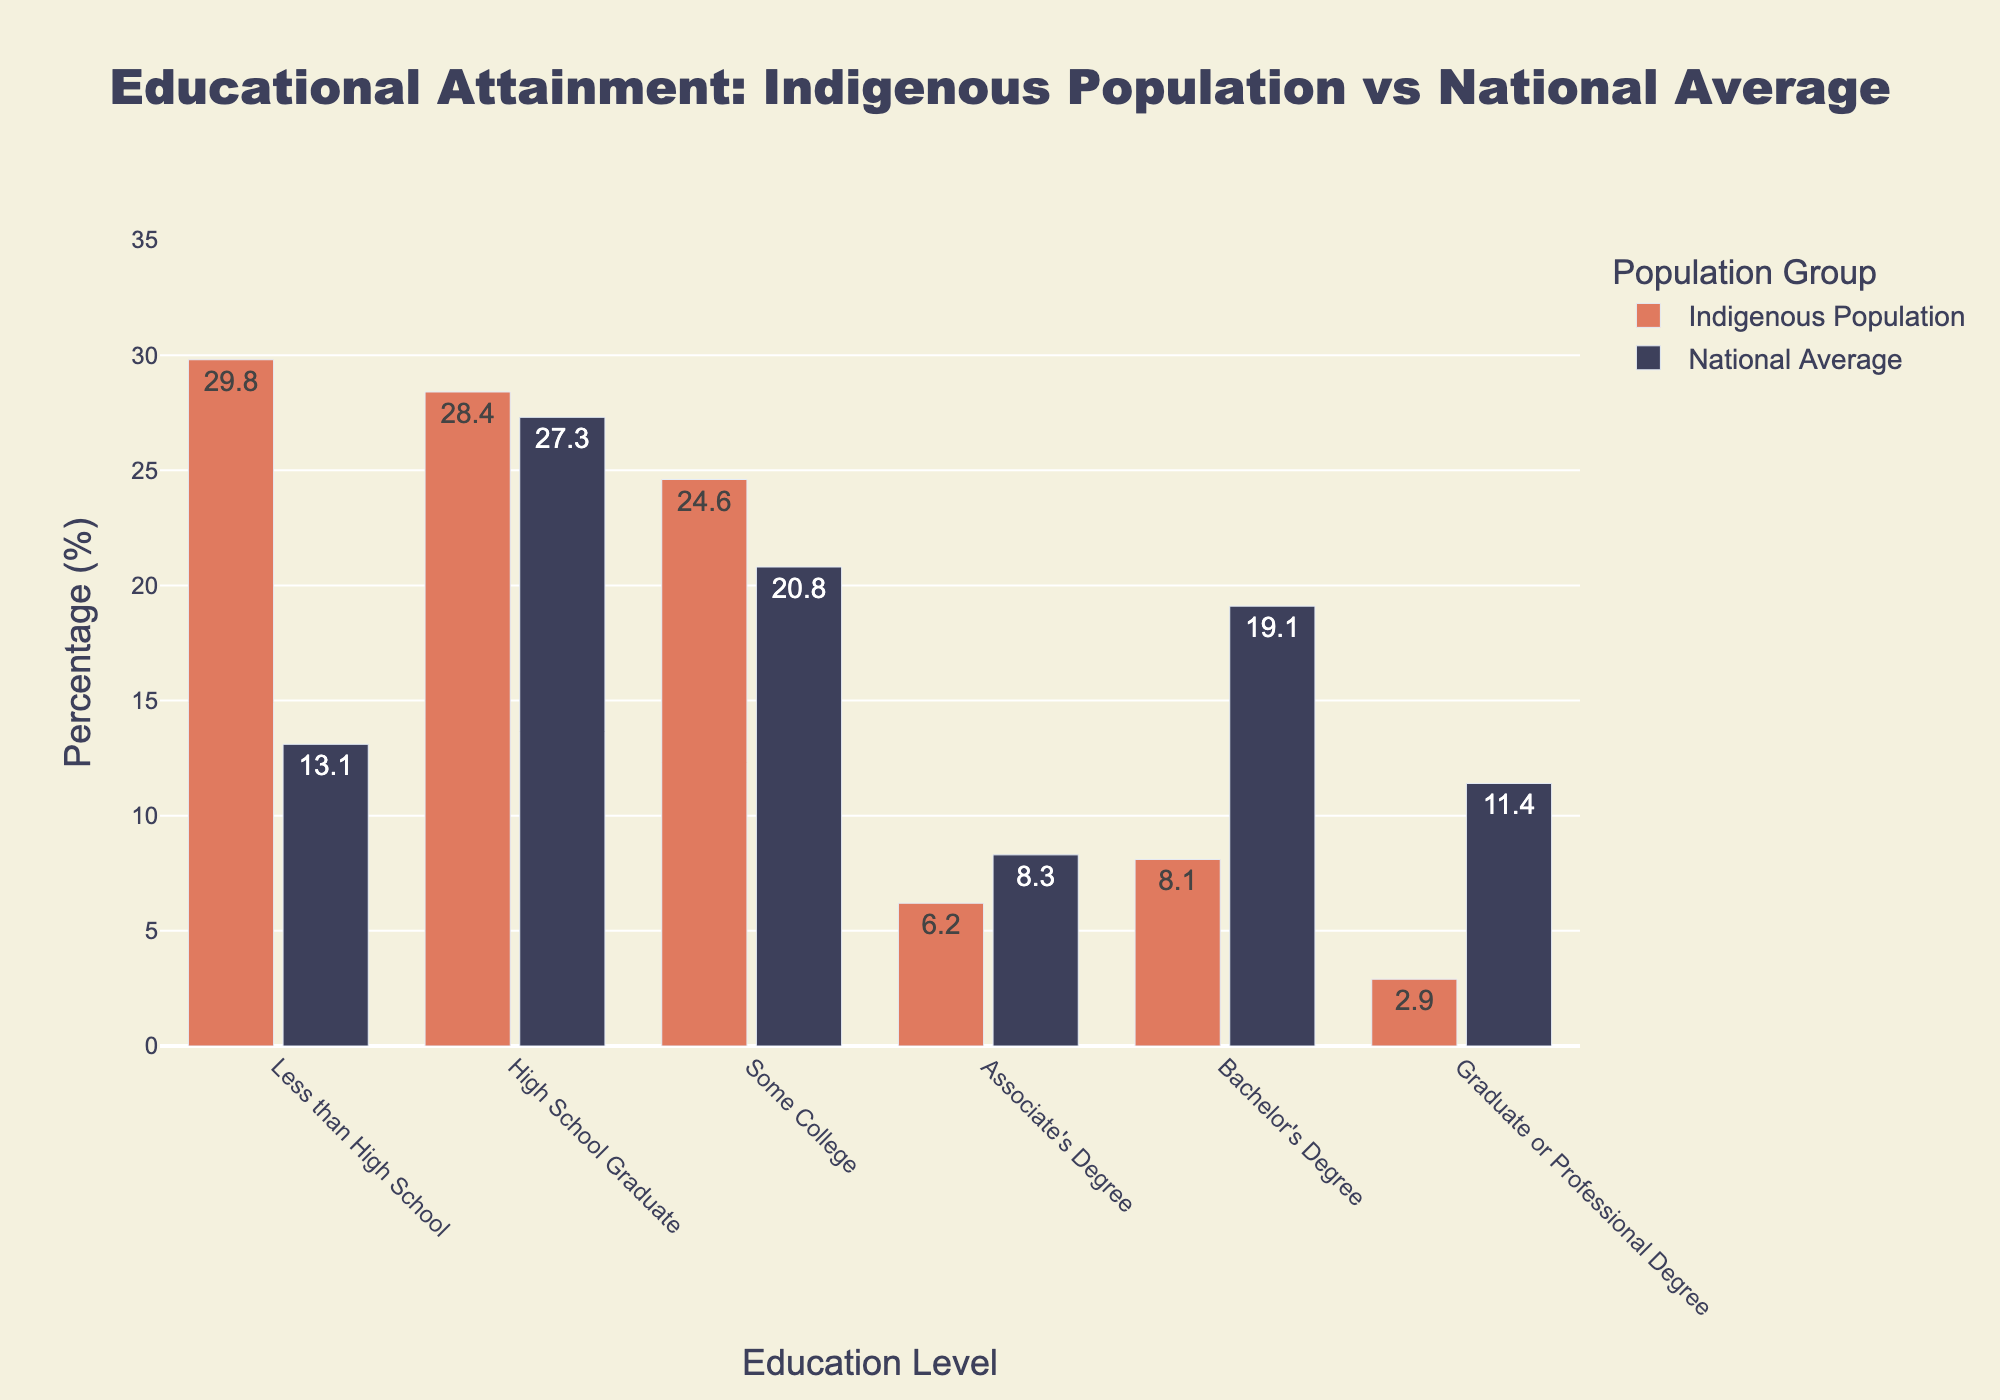What percentage of the Indigenous population has less than a high school education compared to the national average? The bar chart shows that the Indigenous population with less than a high school education is 29.8%, and the national average is 13.1%.
Answer: 29.8% vs. 13.1% Which educational level has the smallest gap between the Indigenous population and the national average? By comparing the differences at each educational level, "High School Graduate" has the smallest gap between the Indigenous population (28.4%) and the national average (27.3%), which is 1.1%.
Answer: High School Graduate Is the percentage of Indigenous individuals with a Bachelor's degree higher or lower than the national average? The percentage of Indigenous individuals with a Bachelor's degree is 8.1%, while the national average is 19.1%. Therefore, it is lower.
Answer: Lower What is the total percentage of the Indigenous population that has either an Associate's, Bachelor's, or Graduate/Professional degree? To find the total percentage, add the percentages for Associate's (6.2%), Bachelor's (8.1%), and Graduate/Professional degrees (2.9%): 6.2 + 8.1 + 2.9 = 17.2%.
Answer: 17.2% What visual element indicates the data for the Indigenous Population in the bar chart? The Indigenous Population data is represented by bars that are colored in red.
Answer: Red bars Which educational level shows the highest discrepancy between the Indigenous population and the national average? The highest discrepancy is observed at the Bachelor's Degree level, where the Indigenous population is at 8.1% compared to the national average of 19.1%, resulting in a discrepancy of 11%.
Answer: Bachelor's Degree Compare the percentages of Indigenous populations with "High School Graduate" and "Some College" education levels. Which one is higher? The percentage of the Indigenous population that are High School Graduates is 28.4%, while those with Some College education is 24.6%. High School Graduate is higher.
Answer: High School Graduate What is the sum of the national average percentages for "High School Graduate" and "Bachelor's Degree"? The national average for "High School Graduate" is 27.3%, and for "Bachelor's Degree" it is 19.1%. Summing these values: 27.3 + 19.1 = 46.4%.
Answer: 46.4% At which educational level do both populations have the closest percentage values? The educational level where both populations' percentages are closest is "High School Graduate" with 28.4% (Indigenous) and 27.3% (National Average), having a difference of 1.1%.
Answer: High School Graduate How much lower is the Indigenous population's percentage for a Graduate or Professional degree compared to the national average? The Indigenous population percentage with a Graduate or Professional degree is 2.9%, while the national average is 11.4%. The difference is 11.4 - 2.9 = 8.5%.
Answer: 8.5% 